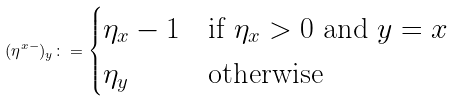Convert formula to latex. <formula><loc_0><loc_0><loc_500><loc_500>( \eta ^ { x - } ) _ { y } \colon = \begin{cases} \eta _ { x } - 1 & \text {if $\eta_{x}>0$ and $y=x$} \\ \eta _ { y } & \text {otherwise} \end{cases}</formula> 